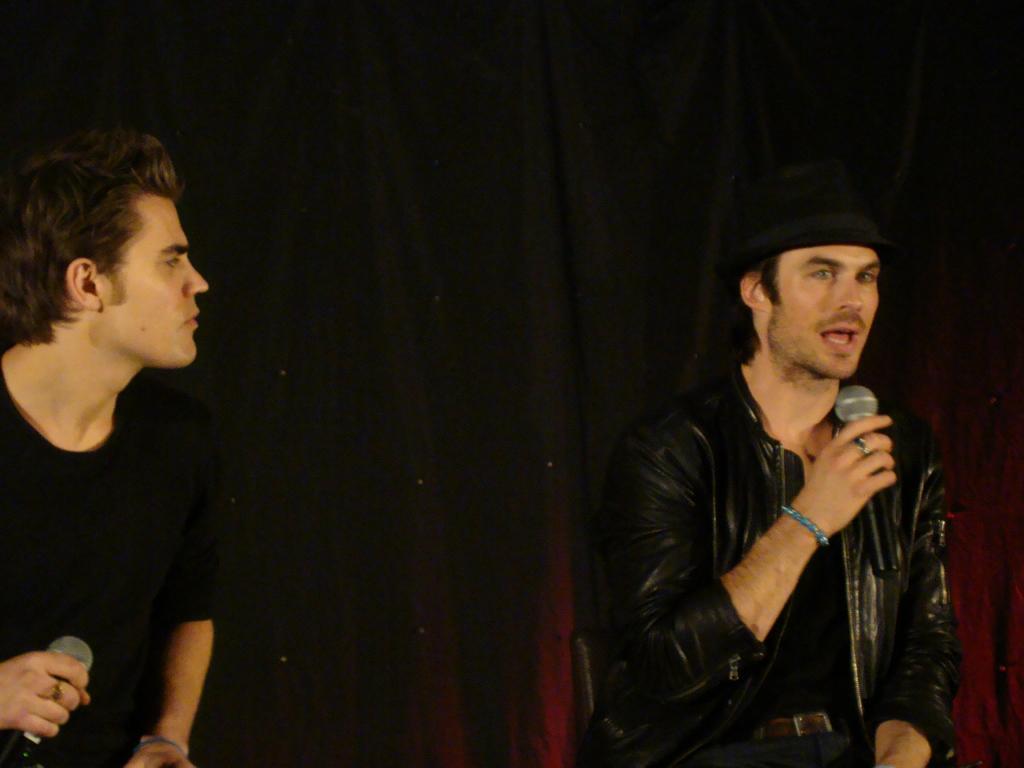Can you describe this image briefly? There are two men holding a microphone. 